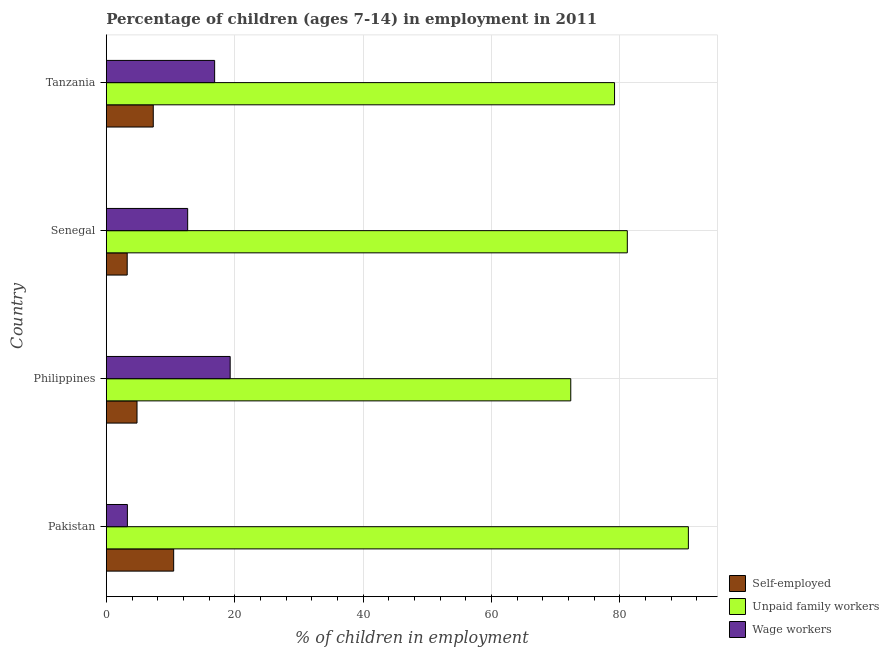What is the label of the 2nd group of bars from the top?
Provide a succinct answer. Senegal. In how many cases, is the number of bars for a given country not equal to the number of legend labels?
Offer a terse response. 0. What is the percentage of children employed as wage workers in Senegal?
Keep it short and to the point. 12.67. Across all countries, what is the maximum percentage of children employed as wage workers?
Give a very brief answer. 19.29. Across all countries, what is the minimum percentage of children employed as unpaid family workers?
Your response must be concise. 72.34. What is the total percentage of self employed children in the graph?
Your answer should be compact. 25.83. What is the difference between the percentage of self employed children in Philippines and that in Senegal?
Your response must be concise. 1.53. What is the difference between the percentage of children employed as unpaid family workers in Philippines and the percentage of children employed as wage workers in Tanzania?
Your response must be concise. 55.47. What is the average percentage of children employed as wage workers per country?
Give a very brief answer. 13.03. What is the difference between the percentage of children employed as wage workers and percentage of self employed children in Senegal?
Keep it short and to the point. 9.42. What is the ratio of the percentage of self employed children in Philippines to that in Tanzania?
Provide a succinct answer. 0.65. Is the difference between the percentage of self employed children in Pakistan and Senegal greater than the difference between the percentage of children employed as wage workers in Pakistan and Senegal?
Offer a terse response. Yes. What is the difference between the highest and the second highest percentage of children employed as wage workers?
Keep it short and to the point. 2.42. What is the difference between the highest and the lowest percentage of children employed as wage workers?
Offer a terse response. 16.01. Is the sum of the percentage of children employed as wage workers in Senegal and Tanzania greater than the maximum percentage of children employed as unpaid family workers across all countries?
Your response must be concise. No. What does the 3rd bar from the top in Senegal represents?
Ensure brevity in your answer.  Self-employed. What does the 2nd bar from the bottom in Tanzania represents?
Give a very brief answer. Unpaid family workers. Is it the case that in every country, the sum of the percentage of self employed children and percentage of children employed as unpaid family workers is greater than the percentage of children employed as wage workers?
Keep it short and to the point. Yes. How many bars are there?
Your answer should be compact. 12. What is the difference between two consecutive major ticks on the X-axis?
Offer a terse response. 20. Are the values on the major ticks of X-axis written in scientific E-notation?
Your answer should be very brief. No. Where does the legend appear in the graph?
Make the answer very short. Bottom right. How many legend labels are there?
Keep it short and to the point. 3. What is the title of the graph?
Ensure brevity in your answer.  Percentage of children (ages 7-14) in employment in 2011. What is the label or title of the X-axis?
Keep it short and to the point. % of children in employment. What is the % of children in employment of Self-employed in Pakistan?
Make the answer very short. 10.49. What is the % of children in employment in Unpaid family workers in Pakistan?
Your answer should be very brief. 90.66. What is the % of children in employment of Wage workers in Pakistan?
Make the answer very short. 3.28. What is the % of children in employment in Self-employed in Philippines?
Make the answer very short. 4.78. What is the % of children in employment of Unpaid family workers in Philippines?
Your answer should be compact. 72.34. What is the % of children in employment in Wage workers in Philippines?
Your answer should be compact. 19.29. What is the % of children in employment in Self-employed in Senegal?
Your answer should be very brief. 3.25. What is the % of children in employment in Unpaid family workers in Senegal?
Your answer should be very brief. 81.15. What is the % of children in employment in Wage workers in Senegal?
Provide a succinct answer. 12.67. What is the % of children in employment in Self-employed in Tanzania?
Make the answer very short. 7.31. What is the % of children in employment in Unpaid family workers in Tanzania?
Keep it short and to the point. 79.16. What is the % of children in employment of Wage workers in Tanzania?
Ensure brevity in your answer.  16.87. Across all countries, what is the maximum % of children in employment in Self-employed?
Make the answer very short. 10.49. Across all countries, what is the maximum % of children in employment in Unpaid family workers?
Your answer should be very brief. 90.66. Across all countries, what is the maximum % of children in employment in Wage workers?
Offer a very short reply. 19.29. Across all countries, what is the minimum % of children in employment in Self-employed?
Offer a terse response. 3.25. Across all countries, what is the minimum % of children in employment of Unpaid family workers?
Your response must be concise. 72.34. Across all countries, what is the minimum % of children in employment of Wage workers?
Keep it short and to the point. 3.28. What is the total % of children in employment in Self-employed in the graph?
Ensure brevity in your answer.  25.83. What is the total % of children in employment of Unpaid family workers in the graph?
Give a very brief answer. 323.31. What is the total % of children in employment of Wage workers in the graph?
Ensure brevity in your answer.  52.11. What is the difference between the % of children in employment of Self-employed in Pakistan and that in Philippines?
Your response must be concise. 5.71. What is the difference between the % of children in employment in Unpaid family workers in Pakistan and that in Philippines?
Offer a terse response. 18.32. What is the difference between the % of children in employment in Wage workers in Pakistan and that in Philippines?
Make the answer very short. -16.01. What is the difference between the % of children in employment in Self-employed in Pakistan and that in Senegal?
Provide a succinct answer. 7.24. What is the difference between the % of children in employment of Unpaid family workers in Pakistan and that in Senegal?
Your answer should be compact. 9.51. What is the difference between the % of children in employment of Wage workers in Pakistan and that in Senegal?
Make the answer very short. -9.39. What is the difference between the % of children in employment of Self-employed in Pakistan and that in Tanzania?
Ensure brevity in your answer.  3.18. What is the difference between the % of children in employment of Unpaid family workers in Pakistan and that in Tanzania?
Provide a short and direct response. 11.5. What is the difference between the % of children in employment of Wage workers in Pakistan and that in Tanzania?
Offer a terse response. -13.59. What is the difference between the % of children in employment in Self-employed in Philippines and that in Senegal?
Make the answer very short. 1.53. What is the difference between the % of children in employment in Unpaid family workers in Philippines and that in Senegal?
Your answer should be very brief. -8.81. What is the difference between the % of children in employment of Wage workers in Philippines and that in Senegal?
Make the answer very short. 6.62. What is the difference between the % of children in employment in Self-employed in Philippines and that in Tanzania?
Offer a very short reply. -2.53. What is the difference between the % of children in employment in Unpaid family workers in Philippines and that in Tanzania?
Keep it short and to the point. -6.82. What is the difference between the % of children in employment in Wage workers in Philippines and that in Tanzania?
Keep it short and to the point. 2.42. What is the difference between the % of children in employment of Self-employed in Senegal and that in Tanzania?
Your answer should be very brief. -4.06. What is the difference between the % of children in employment of Unpaid family workers in Senegal and that in Tanzania?
Your answer should be very brief. 1.99. What is the difference between the % of children in employment of Self-employed in Pakistan and the % of children in employment of Unpaid family workers in Philippines?
Offer a terse response. -61.85. What is the difference between the % of children in employment in Self-employed in Pakistan and the % of children in employment in Wage workers in Philippines?
Provide a succinct answer. -8.8. What is the difference between the % of children in employment of Unpaid family workers in Pakistan and the % of children in employment of Wage workers in Philippines?
Offer a terse response. 71.37. What is the difference between the % of children in employment of Self-employed in Pakistan and the % of children in employment of Unpaid family workers in Senegal?
Provide a short and direct response. -70.66. What is the difference between the % of children in employment in Self-employed in Pakistan and the % of children in employment in Wage workers in Senegal?
Provide a short and direct response. -2.18. What is the difference between the % of children in employment of Unpaid family workers in Pakistan and the % of children in employment of Wage workers in Senegal?
Provide a succinct answer. 77.99. What is the difference between the % of children in employment in Self-employed in Pakistan and the % of children in employment in Unpaid family workers in Tanzania?
Your answer should be compact. -68.67. What is the difference between the % of children in employment of Self-employed in Pakistan and the % of children in employment of Wage workers in Tanzania?
Your response must be concise. -6.38. What is the difference between the % of children in employment of Unpaid family workers in Pakistan and the % of children in employment of Wage workers in Tanzania?
Ensure brevity in your answer.  73.79. What is the difference between the % of children in employment in Self-employed in Philippines and the % of children in employment in Unpaid family workers in Senegal?
Make the answer very short. -76.37. What is the difference between the % of children in employment of Self-employed in Philippines and the % of children in employment of Wage workers in Senegal?
Your response must be concise. -7.89. What is the difference between the % of children in employment in Unpaid family workers in Philippines and the % of children in employment in Wage workers in Senegal?
Make the answer very short. 59.67. What is the difference between the % of children in employment of Self-employed in Philippines and the % of children in employment of Unpaid family workers in Tanzania?
Keep it short and to the point. -74.38. What is the difference between the % of children in employment of Self-employed in Philippines and the % of children in employment of Wage workers in Tanzania?
Your answer should be very brief. -12.09. What is the difference between the % of children in employment of Unpaid family workers in Philippines and the % of children in employment of Wage workers in Tanzania?
Your response must be concise. 55.47. What is the difference between the % of children in employment of Self-employed in Senegal and the % of children in employment of Unpaid family workers in Tanzania?
Make the answer very short. -75.91. What is the difference between the % of children in employment of Self-employed in Senegal and the % of children in employment of Wage workers in Tanzania?
Your answer should be compact. -13.62. What is the difference between the % of children in employment in Unpaid family workers in Senegal and the % of children in employment in Wage workers in Tanzania?
Provide a succinct answer. 64.28. What is the average % of children in employment in Self-employed per country?
Offer a very short reply. 6.46. What is the average % of children in employment in Unpaid family workers per country?
Ensure brevity in your answer.  80.83. What is the average % of children in employment in Wage workers per country?
Make the answer very short. 13.03. What is the difference between the % of children in employment in Self-employed and % of children in employment in Unpaid family workers in Pakistan?
Your response must be concise. -80.17. What is the difference between the % of children in employment in Self-employed and % of children in employment in Wage workers in Pakistan?
Keep it short and to the point. 7.21. What is the difference between the % of children in employment of Unpaid family workers and % of children in employment of Wage workers in Pakistan?
Make the answer very short. 87.38. What is the difference between the % of children in employment of Self-employed and % of children in employment of Unpaid family workers in Philippines?
Offer a terse response. -67.56. What is the difference between the % of children in employment of Self-employed and % of children in employment of Wage workers in Philippines?
Ensure brevity in your answer.  -14.51. What is the difference between the % of children in employment in Unpaid family workers and % of children in employment in Wage workers in Philippines?
Provide a succinct answer. 53.05. What is the difference between the % of children in employment in Self-employed and % of children in employment in Unpaid family workers in Senegal?
Give a very brief answer. -77.9. What is the difference between the % of children in employment of Self-employed and % of children in employment of Wage workers in Senegal?
Provide a succinct answer. -9.42. What is the difference between the % of children in employment in Unpaid family workers and % of children in employment in Wage workers in Senegal?
Provide a short and direct response. 68.48. What is the difference between the % of children in employment of Self-employed and % of children in employment of Unpaid family workers in Tanzania?
Your answer should be very brief. -71.85. What is the difference between the % of children in employment in Self-employed and % of children in employment in Wage workers in Tanzania?
Keep it short and to the point. -9.56. What is the difference between the % of children in employment of Unpaid family workers and % of children in employment of Wage workers in Tanzania?
Your answer should be compact. 62.29. What is the ratio of the % of children in employment in Self-employed in Pakistan to that in Philippines?
Keep it short and to the point. 2.19. What is the ratio of the % of children in employment in Unpaid family workers in Pakistan to that in Philippines?
Offer a terse response. 1.25. What is the ratio of the % of children in employment in Wage workers in Pakistan to that in Philippines?
Your answer should be compact. 0.17. What is the ratio of the % of children in employment in Self-employed in Pakistan to that in Senegal?
Your response must be concise. 3.23. What is the ratio of the % of children in employment of Unpaid family workers in Pakistan to that in Senegal?
Your response must be concise. 1.12. What is the ratio of the % of children in employment of Wage workers in Pakistan to that in Senegal?
Your answer should be compact. 0.26. What is the ratio of the % of children in employment of Self-employed in Pakistan to that in Tanzania?
Provide a succinct answer. 1.44. What is the ratio of the % of children in employment of Unpaid family workers in Pakistan to that in Tanzania?
Ensure brevity in your answer.  1.15. What is the ratio of the % of children in employment of Wage workers in Pakistan to that in Tanzania?
Your answer should be compact. 0.19. What is the ratio of the % of children in employment in Self-employed in Philippines to that in Senegal?
Provide a short and direct response. 1.47. What is the ratio of the % of children in employment in Unpaid family workers in Philippines to that in Senegal?
Provide a succinct answer. 0.89. What is the ratio of the % of children in employment of Wage workers in Philippines to that in Senegal?
Make the answer very short. 1.52. What is the ratio of the % of children in employment of Self-employed in Philippines to that in Tanzania?
Give a very brief answer. 0.65. What is the ratio of the % of children in employment in Unpaid family workers in Philippines to that in Tanzania?
Give a very brief answer. 0.91. What is the ratio of the % of children in employment of Wage workers in Philippines to that in Tanzania?
Make the answer very short. 1.14. What is the ratio of the % of children in employment in Self-employed in Senegal to that in Tanzania?
Your answer should be compact. 0.44. What is the ratio of the % of children in employment in Unpaid family workers in Senegal to that in Tanzania?
Your answer should be compact. 1.03. What is the ratio of the % of children in employment in Wage workers in Senegal to that in Tanzania?
Provide a succinct answer. 0.75. What is the difference between the highest and the second highest % of children in employment of Self-employed?
Give a very brief answer. 3.18. What is the difference between the highest and the second highest % of children in employment of Unpaid family workers?
Your response must be concise. 9.51. What is the difference between the highest and the second highest % of children in employment in Wage workers?
Your response must be concise. 2.42. What is the difference between the highest and the lowest % of children in employment in Self-employed?
Provide a succinct answer. 7.24. What is the difference between the highest and the lowest % of children in employment of Unpaid family workers?
Make the answer very short. 18.32. What is the difference between the highest and the lowest % of children in employment in Wage workers?
Make the answer very short. 16.01. 